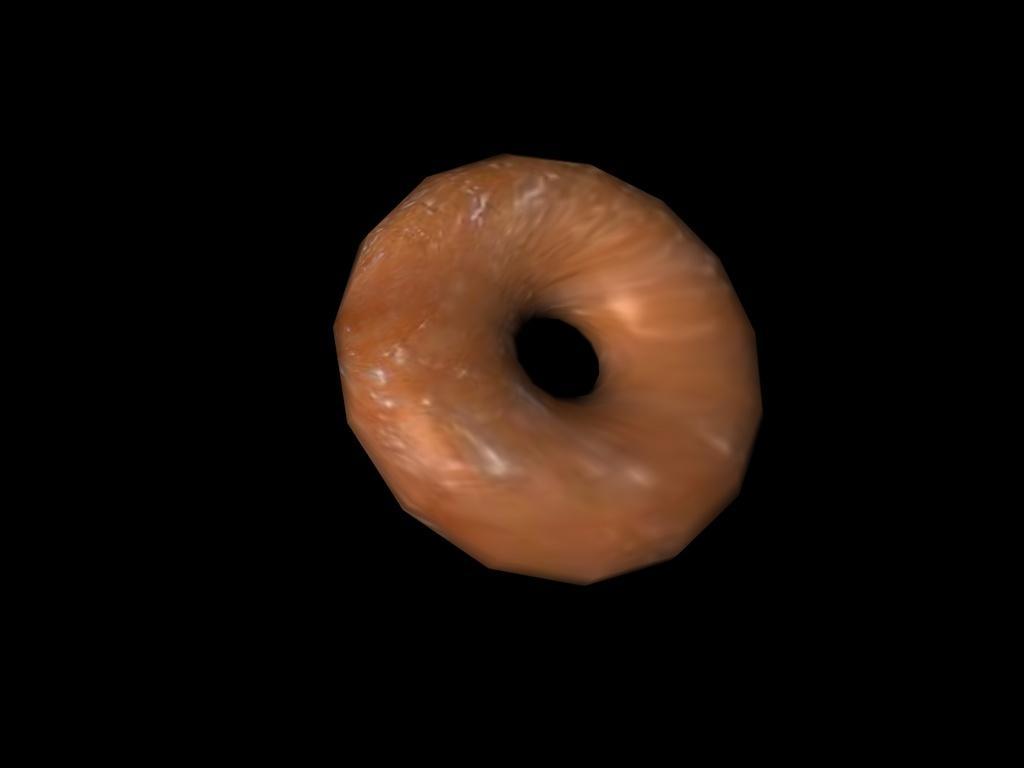In one or two sentences, can you explain what this image depicts? This image consist of a doughnut. 